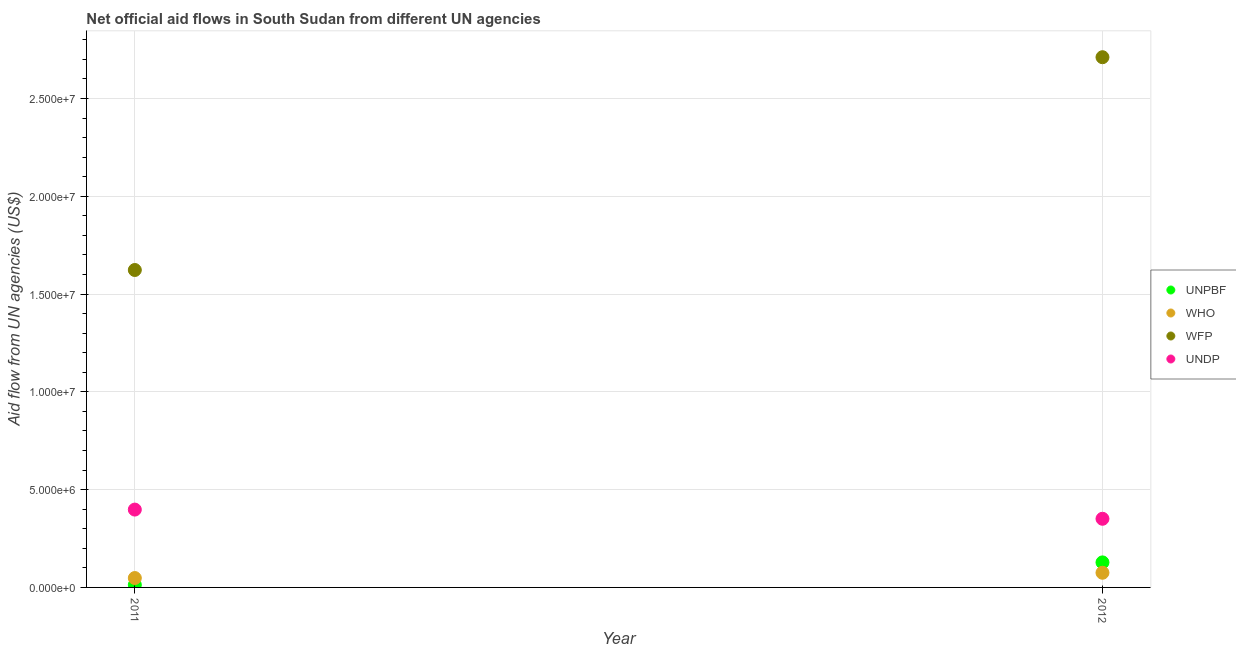What is the amount of aid given by wfp in 2012?
Keep it short and to the point. 2.71e+07. Across all years, what is the maximum amount of aid given by unpbf?
Your answer should be very brief. 1.28e+06. Across all years, what is the minimum amount of aid given by undp?
Provide a succinct answer. 3.51e+06. In which year was the amount of aid given by who maximum?
Offer a terse response. 2012. In which year was the amount of aid given by wfp minimum?
Offer a terse response. 2011. What is the total amount of aid given by unpbf in the graph?
Your answer should be very brief. 1.41e+06. What is the difference between the amount of aid given by wfp in 2011 and that in 2012?
Provide a succinct answer. -1.09e+07. What is the difference between the amount of aid given by unpbf in 2011 and the amount of aid given by undp in 2012?
Provide a succinct answer. -3.38e+06. What is the average amount of aid given by wfp per year?
Make the answer very short. 2.17e+07. In the year 2011, what is the difference between the amount of aid given by wfp and amount of aid given by unpbf?
Keep it short and to the point. 1.61e+07. What is the ratio of the amount of aid given by unpbf in 2011 to that in 2012?
Offer a very short reply. 0.1. Is the amount of aid given by unpbf in 2011 less than that in 2012?
Offer a terse response. Yes. Is the amount of aid given by who strictly greater than the amount of aid given by wfp over the years?
Offer a terse response. No. Is the amount of aid given by undp strictly less than the amount of aid given by who over the years?
Provide a succinct answer. No. How many years are there in the graph?
Offer a very short reply. 2. Does the graph contain any zero values?
Give a very brief answer. No. Where does the legend appear in the graph?
Give a very brief answer. Center right. How many legend labels are there?
Your answer should be compact. 4. How are the legend labels stacked?
Provide a short and direct response. Vertical. What is the title of the graph?
Keep it short and to the point. Net official aid flows in South Sudan from different UN agencies. What is the label or title of the X-axis?
Keep it short and to the point. Year. What is the label or title of the Y-axis?
Make the answer very short. Aid flow from UN agencies (US$). What is the Aid flow from UN agencies (US$) in UNPBF in 2011?
Offer a very short reply. 1.30e+05. What is the Aid flow from UN agencies (US$) in WFP in 2011?
Provide a short and direct response. 1.62e+07. What is the Aid flow from UN agencies (US$) of UNDP in 2011?
Give a very brief answer. 3.98e+06. What is the Aid flow from UN agencies (US$) of UNPBF in 2012?
Offer a terse response. 1.28e+06. What is the Aid flow from UN agencies (US$) of WHO in 2012?
Keep it short and to the point. 7.50e+05. What is the Aid flow from UN agencies (US$) in WFP in 2012?
Offer a very short reply. 2.71e+07. What is the Aid flow from UN agencies (US$) in UNDP in 2012?
Provide a short and direct response. 3.51e+06. Across all years, what is the maximum Aid flow from UN agencies (US$) of UNPBF?
Keep it short and to the point. 1.28e+06. Across all years, what is the maximum Aid flow from UN agencies (US$) in WHO?
Provide a succinct answer. 7.50e+05. Across all years, what is the maximum Aid flow from UN agencies (US$) of WFP?
Your answer should be compact. 2.71e+07. Across all years, what is the maximum Aid flow from UN agencies (US$) of UNDP?
Give a very brief answer. 3.98e+06. Across all years, what is the minimum Aid flow from UN agencies (US$) in UNPBF?
Make the answer very short. 1.30e+05. Across all years, what is the minimum Aid flow from UN agencies (US$) in WFP?
Keep it short and to the point. 1.62e+07. Across all years, what is the minimum Aid flow from UN agencies (US$) in UNDP?
Offer a very short reply. 3.51e+06. What is the total Aid flow from UN agencies (US$) in UNPBF in the graph?
Keep it short and to the point. 1.41e+06. What is the total Aid flow from UN agencies (US$) of WHO in the graph?
Offer a very short reply. 1.23e+06. What is the total Aid flow from UN agencies (US$) of WFP in the graph?
Your answer should be compact. 4.33e+07. What is the total Aid flow from UN agencies (US$) in UNDP in the graph?
Keep it short and to the point. 7.49e+06. What is the difference between the Aid flow from UN agencies (US$) of UNPBF in 2011 and that in 2012?
Ensure brevity in your answer.  -1.15e+06. What is the difference between the Aid flow from UN agencies (US$) of WFP in 2011 and that in 2012?
Provide a short and direct response. -1.09e+07. What is the difference between the Aid flow from UN agencies (US$) of UNDP in 2011 and that in 2012?
Provide a short and direct response. 4.70e+05. What is the difference between the Aid flow from UN agencies (US$) in UNPBF in 2011 and the Aid flow from UN agencies (US$) in WHO in 2012?
Make the answer very short. -6.20e+05. What is the difference between the Aid flow from UN agencies (US$) of UNPBF in 2011 and the Aid flow from UN agencies (US$) of WFP in 2012?
Provide a succinct answer. -2.70e+07. What is the difference between the Aid flow from UN agencies (US$) of UNPBF in 2011 and the Aid flow from UN agencies (US$) of UNDP in 2012?
Provide a succinct answer. -3.38e+06. What is the difference between the Aid flow from UN agencies (US$) of WHO in 2011 and the Aid flow from UN agencies (US$) of WFP in 2012?
Keep it short and to the point. -2.66e+07. What is the difference between the Aid flow from UN agencies (US$) in WHO in 2011 and the Aid flow from UN agencies (US$) in UNDP in 2012?
Make the answer very short. -3.03e+06. What is the difference between the Aid flow from UN agencies (US$) in WFP in 2011 and the Aid flow from UN agencies (US$) in UNDP in 2012?
Offer a very short reply. 1.27e+07. What is the average Aid flow from UN agencies (US$) in UNPBF per year?
Your answer should be very brief. 7.05e+05. What is the average Aid flow from UN agencies (US$) in WHO per year?
Your answer should be very brief. 6.15e+05. What is the average Aid flow from UN agencies (US$) in WFP per year?
Your answer should be very brief. 2.17e+07. What is the average Aid flow from UN agencies (US$) in UNDP per year?
Give a very brief answer. 3.74e+06. In the year 2011, what is the difference between the Aid flow from UN agencies (US$) in UNPBF and Aid flow from UN agencies (US$) in WHO?
Your response must be concise. -3.50e+05. In the year 2011, what is the difference between the Aid flow from UN agencies (US$) in UNPBF and Aid flow from UN agencies (US$) in WFP?
Provide a short and direct response. -1.61e+07. In the year 2011, what is the difference between the Aid flow from UN agencies (US$) of UNPBF and Aid flow from UN agencies (US$) of UNDP?
Provide a succinct answer. -3.85e+06. In the year 2011, what is the difference between the Aid flow from UN agencies (US$) in WHO and Aid flow from UN agencies (US$) in WFP?
Your response must be concise. -1.58e+07. In the year 2011, what is the difference between the Aid flow from UN agencies (US$) in WHO and Aid flow from UN agencies (US$) in UNDP?
Keep it short and to the point. -3.50e+06. In the year 2011, what is the difference between the Aid flow from UN agencies (US$) in WFP and Aid flow from UN agencies (US$) in UNDP?
Provide a succinct answer. 1.22e+07. In the year 2012, what is the difference between the Aid flow from UN agencies (US$) of UNPBF and Aid flow from UN agencies (US$) of WHO?
Give a very brief answer. 5.30e+05. In the year 2012, what is the difference between the Aid flow from UN agencies (US$) of UNPBF and Aid flow from UN agencies (US$) of WFP?
Keep it short and to the point. -2.58e+07. In the year 2012, what is the difference between the Aid flow from UN agencies (US$) in UNPBF and Aid flow from UN agencies (US$) in UNDP?
Your answer should be very brief. -2.23e+06. In the year 2012, what is the difference between the Aid flow from UN agencies (US$) in WHO and Aid flow from UN agencies (US$) in WFP?
Your response must be concise. -2.64e+07. In the year 2012, what is the difference between the Aid flow from UN agencies (US$) in WHO and Aid flow from UN agencies (US$) in UNDP?
Provide a succinct answer. -2.76e+06. In the year 2012, what is the difference between the Aid flow from UN agencies (US$) in WFP and Aid flow from UN agencies (US$) in UNDP?
Your response must be concise. 2.36e+07. What is the ratio of the Aid flow from UN agencies (US$) of UNPBF in 2011 to that in 2012?
Keep it short and to the point. 0.1. What is the ratio of the Aid flow from UN agencies (US$) of WHO in 2011 to that in 2012?
Make the answer very short. 0.64. What is the ratio of the Aid flow from UN agencies (US$) of WFP in 2011 to that in 2012?
Offer a terse response. 0.6. What is the ratio of the Aid flow from UN agencies (US$) in UNDP in 2011 to that in 2012?
Your response must be concise. 1.13. What is the difference between the highest and the second highest Aid flow from UN agencies (US$) in UNPBF?
Provide a short and direct response. 1.15e+06. What is the difference between the highest and the second highest Aid flow from UN agencies (US$) in WFP?
Your answer should be very brief. 1.09e+07. What is the difference between the highest and the second highest Aid flow from UN agencies (US$) in UNDP?
Give a very brief answer. 4.70e+05. What is the difference between the highest and the lowest Aid flow from UN agencies (US$) of UNPBF?
Provide a short and direct response. 1.15e+06. What is the difference between the highest and the lowest Aid flow from UN agencies (US$) in WHO?
Your response must be concise. 2.70e+05. What is the difference between the highest and the lowest Aid flow from UN agencies (US$) of WFP?
Ensure brevity in your answer.  1.09e+07. 